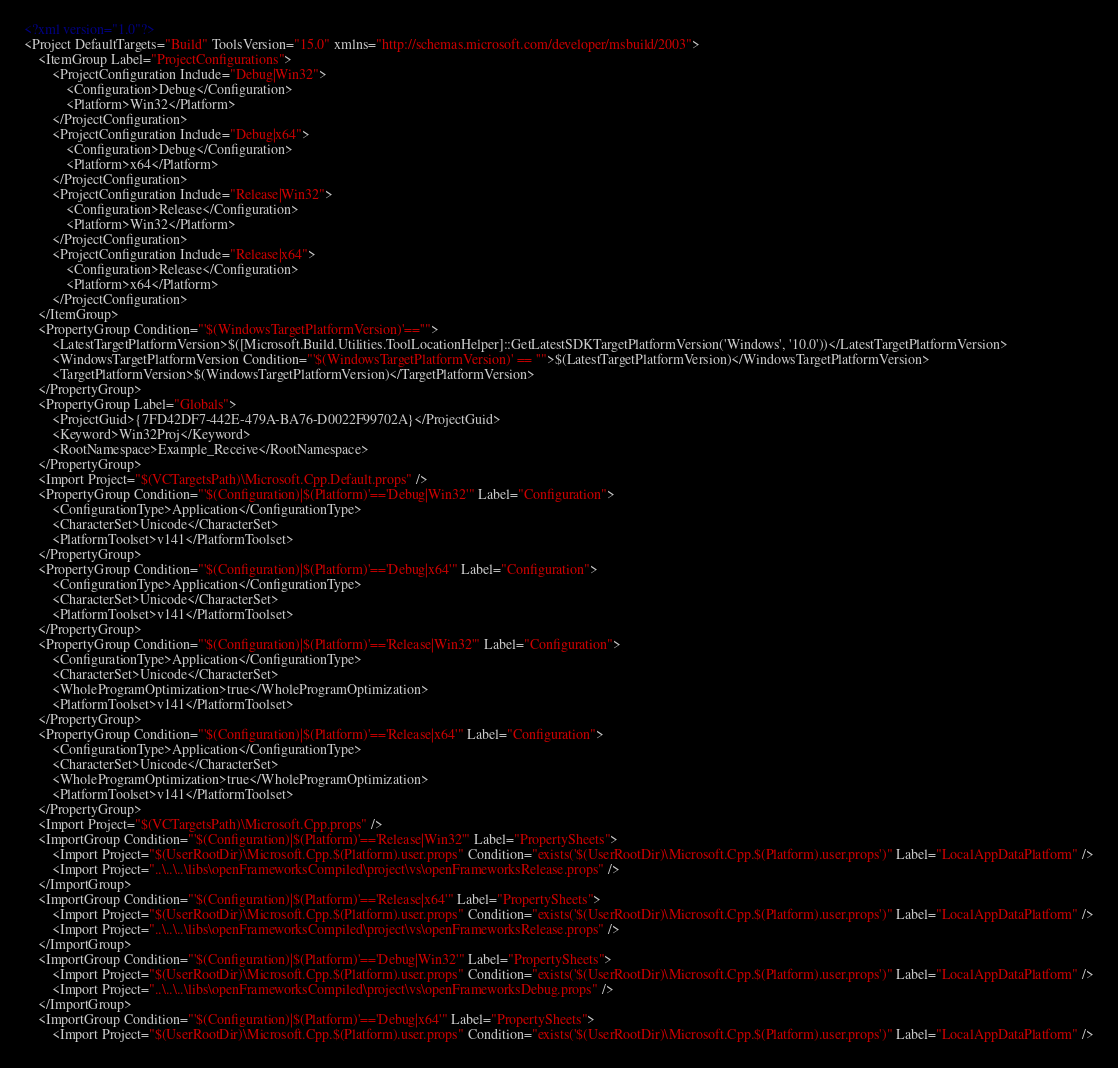Convert code to text. <code><loc_0><loc_0><loc_500><loc_500><_XML_><?xml version="1.0"?>
<Project DefaultTargets="Build" ToolsVersion="15.0" xmlns="http://schemas.microsoft.com/developer/msbuild/2003">
	<ItemGroup Label="ProjectConfigurations">
		<ProjectConfiguration Include="Debug|Win32">
			<Configuration>Debug</Configuration>
			<Platform>Win32</Platform>
		</ProjectConfiguration>
		<ProjectConfiguration Include="Debug|x64">
			<Configuration>Debug</Configuration>
			<Platform>x64</Platform>
		</ProjectConfiguration>
		<ProjectConfiguration Include="Release|Win32">
			<Configuration>Release</Configuration>
			<Platform>Win32</Platform>
		</ProjectConfiguration>
		<ProjectConfiguration Include="Release|x64">
			<Configuration>Release</Configuration>
			<Platform>x64</Platform>
		</ProjectConfiguration>
	</ItemGroup>
	<PropertyGroup Condition="'$(WindowsTargetPlatformVersion)'==''">
		<LatestTargetPlatformVersion>$([Microsoft.Build.Utilities.ToolLocationHelper]::GetLatestSDKTargetPlatformVersion('Windows', '10.0'))</LatestTargetPlatformVersion>
		<WindowsTargetPlatformVersion Condition="'$(WindowsTargetPlatformVersion)' == ''">$(LatestTargetPlatformVersion)</WindowsTargetPlatformVersion>
		<TargetPlatformVersion>$(WindowsTargetPlatformVersion)</TargetPlatformVersion>
	</PropertyGroup>
	<PropertyGroup Label="Globals">
		<ProjectGuid>{7FD42DF7-442E-479A-BA76-D0022F99702A}</ProjectGuid>
		<Keyword>Win32Proj</Keyword>
		<RootNamespace>Example_Receive</RootNamespace>
	</PropertyGroup>
	<Import Project="$(VCTargetsPath)\Microsoft.Cpp.Default.props" />
	<PropertyGroup Condition="'$(Configuration)|$(Platform)'=='Debug|Win32'" Label="Configuration">
		<ConfigurationType>Application</ConfigurationType>
		<CharacterSet>Unicode</CharacterSet>
		<PlatformToolset>v141</PlatformToolset>
	</PropertyGroup>
	<PropertyGroup Condition="'$(Configuration)|$(Platform)'=='Debug|x64'" Label="Configuration">
		<ConfigurationType>Application</ConfigurationType>
		<CharacterSet>Unicode</CharacterSet>
		<PlatformToolset>v141</PlatformToolset>
	</PropertyGroup>
	<PropertyGroup Condition="'$(Configuration)|$(Platform)'=='Release|Win32'" Label="Configuration">
		<ConfigurationType>Application</ConfigurationType>
		<CharacterSet>Unicode</CharacterSet>
		<WholeProgramOptimization>true</WholeProgramOptimization>
		<PlatformToolset>v141</PlatformToolset>
	</PropertyGroup>
	<PropertyGroup Condition="'$(Configuration)|$(Platform)'=='Release|x64'" Label="Configuration">
		<ConfigurationType>Application</ConfigurationType>
		<CharacterSet>Unicode</CharacterSet>
		<WholeProgramOptimization>true</WholeProgramOptimization>
		<PlatformToolset>v141</PlatformToolset>
	</PropertyGroup>
	<Import Project="$(VCTargetsPath)\Microsoft.Cpp.props" />
	<ImportGroup Condition="'$(Configuration)|$(Platform)'=='Release|Win32'" Label="PropertySheets">
		<Import Project="$(UserRootDir)\Microsoft.Cpp.$(Platform).user.props" Condition="exists('$(UserRootDir)\Microsoft.Cpp.$(Platform).user.props')" Label="LocalAppDataPlatform" />
		<Import Project="..\..\..\libs\openFrameworksCompiled\project\vs\openFrameworksRelease.props" />
	</ImportGroup>
	<ImportGroup Condition="'$(Configuration)|$(Platform)'=='Release|x64'" Label="PropertySheets">
		<Import Project="$(UserRootDir)\Microsoft.Cpp.$(Platform).user.props" Condition="exists('$(UserRootDir)\Microsoft.Cpp.$(Platform).user.props')" Label="LocalAppDataPlatform" />
		<Import Project="..\..\..\libs\openFrameworksCompiled\project\vs\openFrameworksRelease.props" />
	</ImportGroup>
	<ImportGroup Condition="'$(Configuration)|$(Platform)'=='Debug|Win32'" Label="PropertySheets">
		<Import Project="$(UserRootDir)\Microsoft.Cpp.$(Platform).user.props" Condition="exists('$(UserRootDir)\Microsoft.Cpp.$(Platform).user.props')" Label="LocalAppDataPlatform" />
		<Import Project="..\..\..\libs\openFrameworksCompiled\project\vs\openFrameworksDebug.props" />
	</ImportGroup>
	<ImportGroup Condition="'$(Configuration)|$(Platform)'=='Debug|x64'" Label="PropertySheets">
		<Import Project="$(UserRootDir)\Microsoft.Cpp.$(Platform).user.props" Condition="exists('$(UserRootDir)\Microsoft.Cpp.$(Platform).user.props')" Label="LocalAppDataPlatform" /></code> 